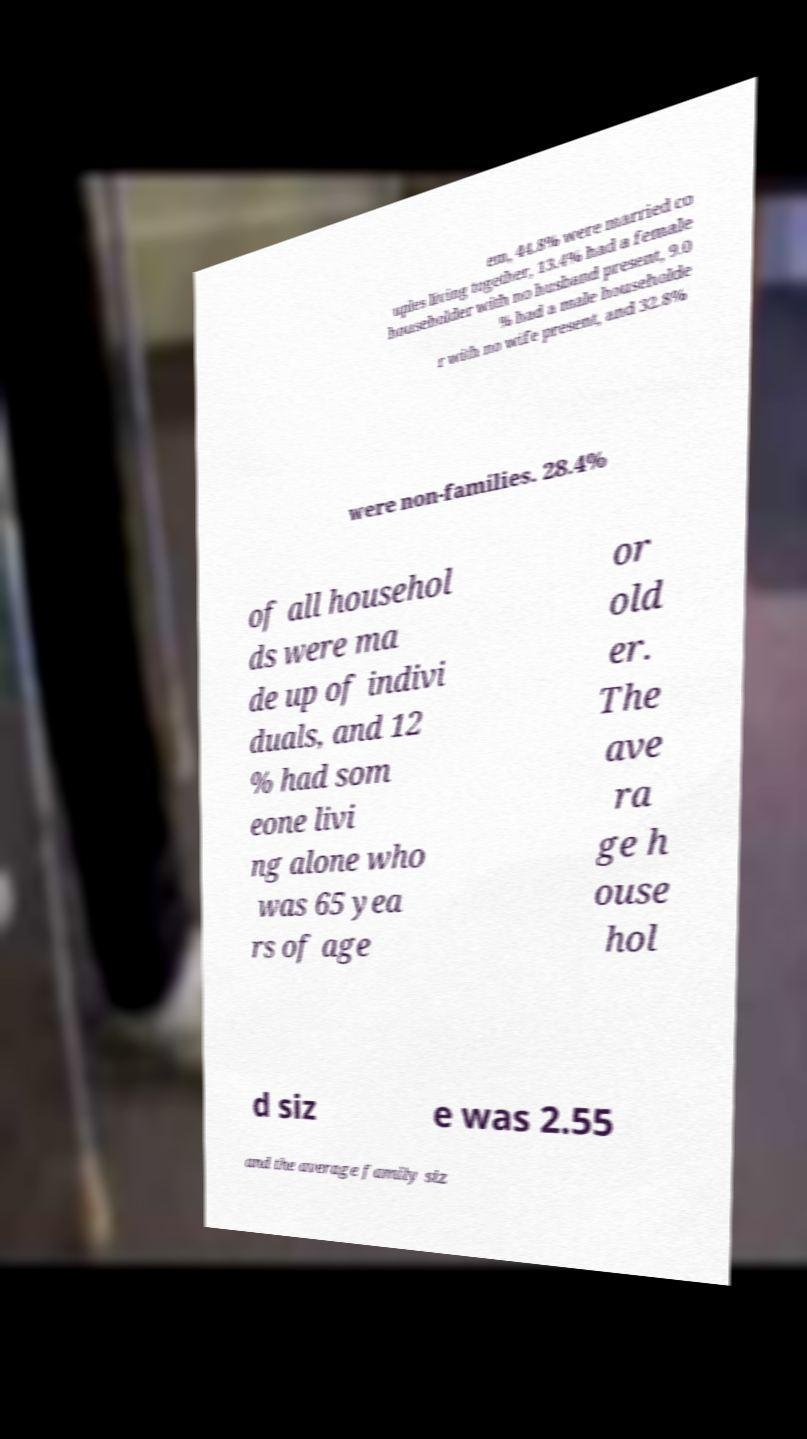Can you accurately transcribe the text from the provided image for me? em, 44.8% were married co uples living together, 13.4% had a female householder with no husband present, 9.0 % had a male householde r with no wife present, and 32.8% were non-families. 28.4% of all househol ds were ma de up of indivi duals, and 12 % had som eone livi ng alone who was 65 yea rs of age or old er. The ave ra ge h ouse hol d siz e was 2.55 and the average family siz 